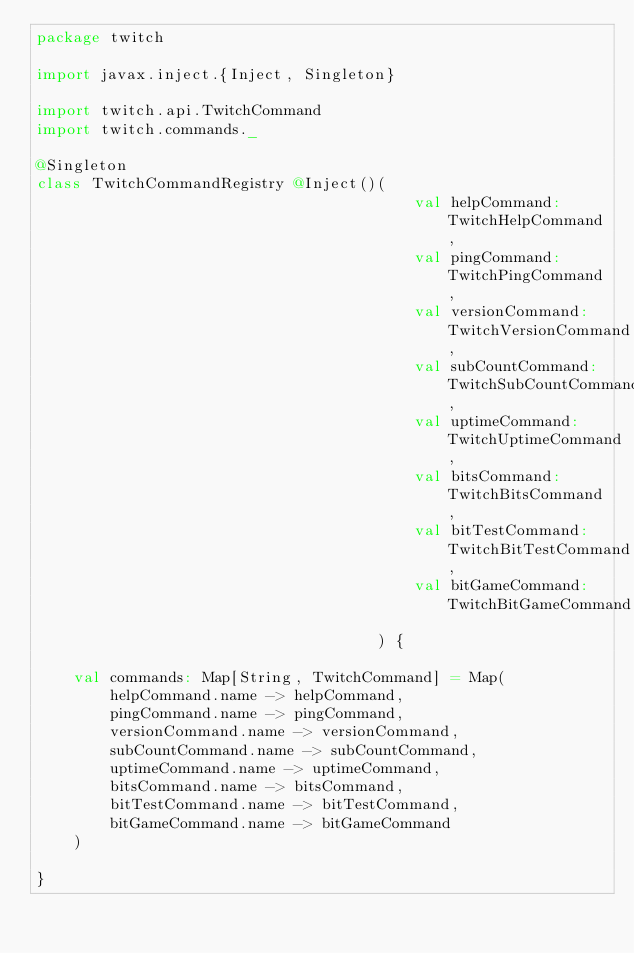<code> <loc_0><loc_0><loc_500><loc_500><_Scala_>package twitch

import javax.inject.{Inject, Singleton}

import twitch.api.TwitchCommand
import twitch.commands._

@Singleton
class TwitchCommandRegistry @Inject()(
                                         val helpCommand: TwitchHelpCommand,
                                         val pingCommand: TwitchPingCommand,
                                         val versionCommand: TwitchVersionCommand,
                                         val subCountCommand: TwitchSubCountCommand,
                                         val uptimeCommand: TwitchUptimeCommand,
                                         val bitsCommand: TwitchBitsCommand,
                                         val bitTestCommand: TwitchBitTestCommand,
                                         val bitGameCommand: TwitchBitGameCommand
                                     ) {

    val commands: Map[String, TwitchCommand] = Map(
        helpCommand.name -> helpCommand,
        pingCommand.name -> pingCommand,
        versionCommand.name -> versionCommand,
        subCountCommand.name -> subCountCommand,
        uptimeCommand.name -> uptimeCommand,
        bitsCommand.name -> bitsCommand,
        bitTestCommand.name -> bitTestCommand,
        bitGameCommand.name -> bitGameCommand
    )

}
</code> 